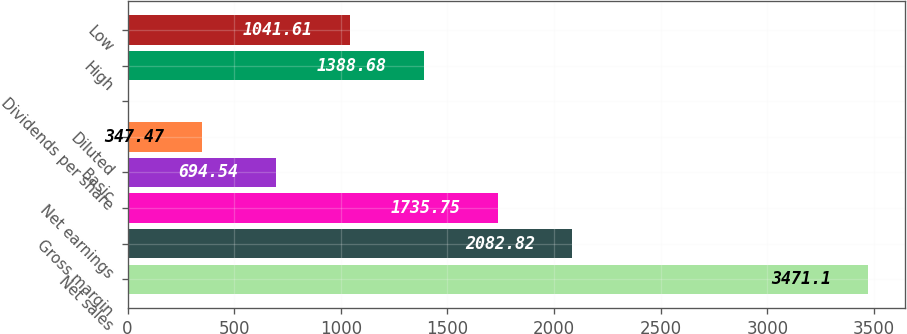<chart> <loc_0><loc_0><loc_500><loc_500><bar_chart><fcel>Net sales<fcel>Gross margin<fcel>Net earnings<fcel>Basic<fcel>Diluted<fcel>Dividends per share<fcel>High<fcel>Low<nl><fcel>3471.1<fcel>2082.82<fcel>1735.75<fcel>694.54<fcel>347.47<fcel>0.4<fcel>1388.68<fcel>1041.61<nl></chart> 